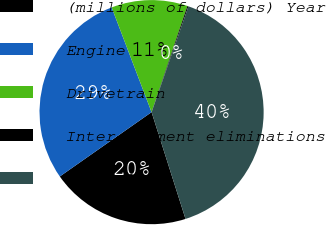Convert chart. <chart><loc_0><loc_0><loc_500><loc_500><pie_chart><fcel>(millions of dollars) Year<fcel>Engine<fcel>Drivetrain<fcel>Inter-segment eliminations<fcel>Net sales<nl><fcel>20.17%<fcel>28.94%<fcel>10.98%<fcel>0.15%<fcel>39.77%<nl></chart> 